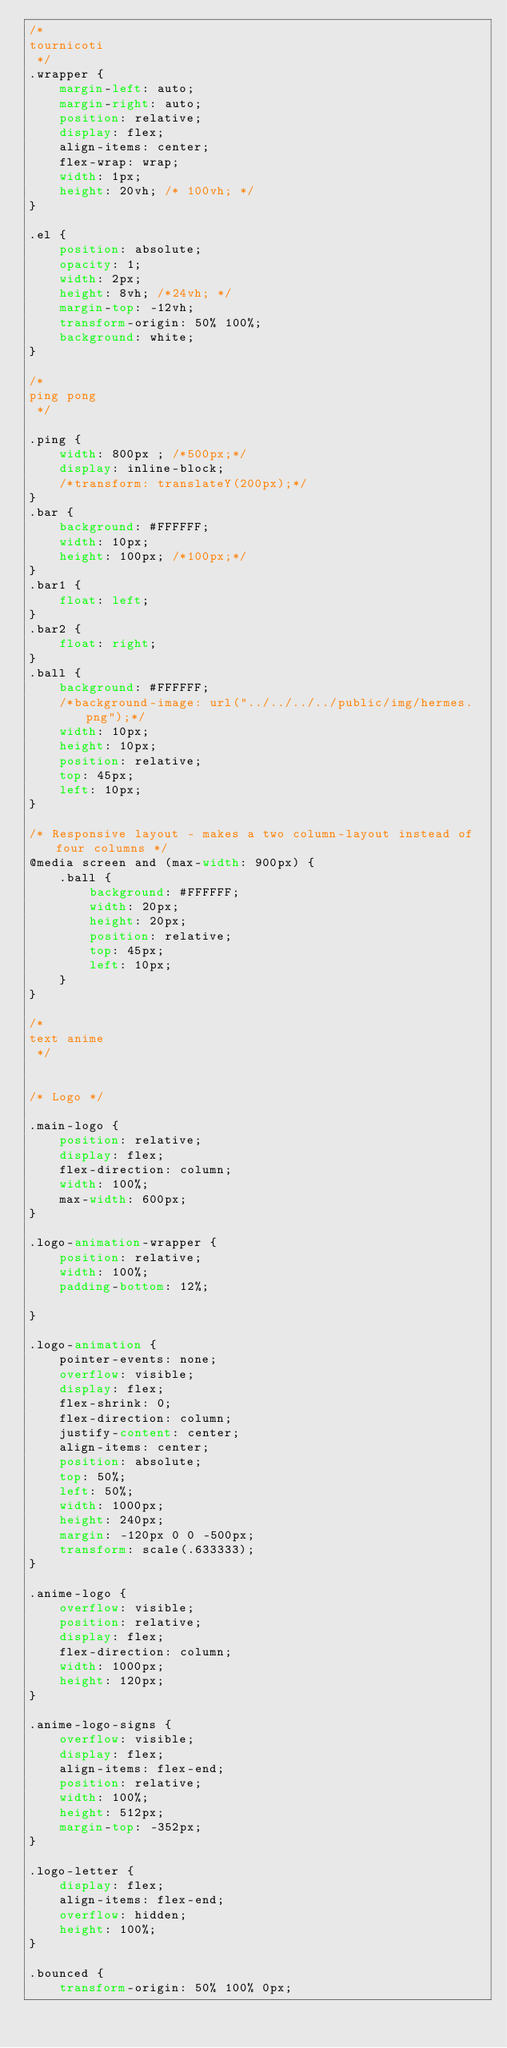<code> <loc_0><loc_0><loc_500><loc_500><_CSS_>/*
tournicoti
 */
.wrapper {
    margin-left: auto;
    margin-right: auto;
    position: relative;
    display: flex;
    align-items: center;
    flex-wrap: wrap;
    width: 1px;
    height: 20vh; /* 100vh; */
}

.el {
    position: absolute;
    opacity: 1;
    width: 2px;
    height: 8vh; /*24vh; */
    margin-top: -12vh;
    transform-origin: 50% 100%;
    background: white;
}

/*
ping pong
 */

.ping {
    width: 800px ; /*500px;*/
    display: inline-block;
    /*transform: translateY(200px);*/
}
.bar {
    background: #FFFFFF;
    width: 10px;
    height: 100px; /*100px;*/
}
.bar1 {
    float: left;
}
.bar2 {
    float: right;
}
.ball {
    background: #FFFFFF;
    /*background-image: url("../../../../public/img/hermes.png");*/
    width: 10px;
    height: 10px;
    position: relative;
    top: 45px;
    left: 10px;
}

/* Responsive layout - makes a two column-layout instead of four columns */
@media screen and (max-width: 900px) {
    .ball {
        background: #FFFFFF;
        width: 20px;
        height: 20px;
        position: relative;
        top: 45px;
        left: 10px;
    }
}

/*
text anime
 */


/* Logo */

.main-logo {
    position: relative;
    display: flex;
    flex-direction: column;
    width: 100%;
    max-width: 600px;
}

.logo-animation-wrapper {
    position: relative;
    width: 100%;
    padding-bottom: 12%;

}

.logo-animation {
    pointer-events: none;
    overflow: visible;
    display: flex;
    flex-shrink: 0;
    flex-direction: column;
    justify-content: center;
    align-items: center;
    position: absolute;
    top: 50%;
    left: 50%;
    width: 1000px;
    height: 240px;
    margin: -120px 0 0 -500px;
    transform: scale(.633333);
}

.anime-logo {
    overflow: visible;
    position: relative;
    display: flex;
    flex-direction: column;
    width: 1000px;
    height: 120px;
}

.anime-logo-signs {
    overflow: visible;
    display: flex;
    align-items: flex-end;
    position: relative;
    width: 100%;
    height: 512px;
    margin-top: -352px;
}

.logo-letter {
    display: flex;
    align-items: flex-end;
    overflow: hidden;
    height: 100%;
}

.bounced {
    transform-origin: 50% 100% 0px;</code> 